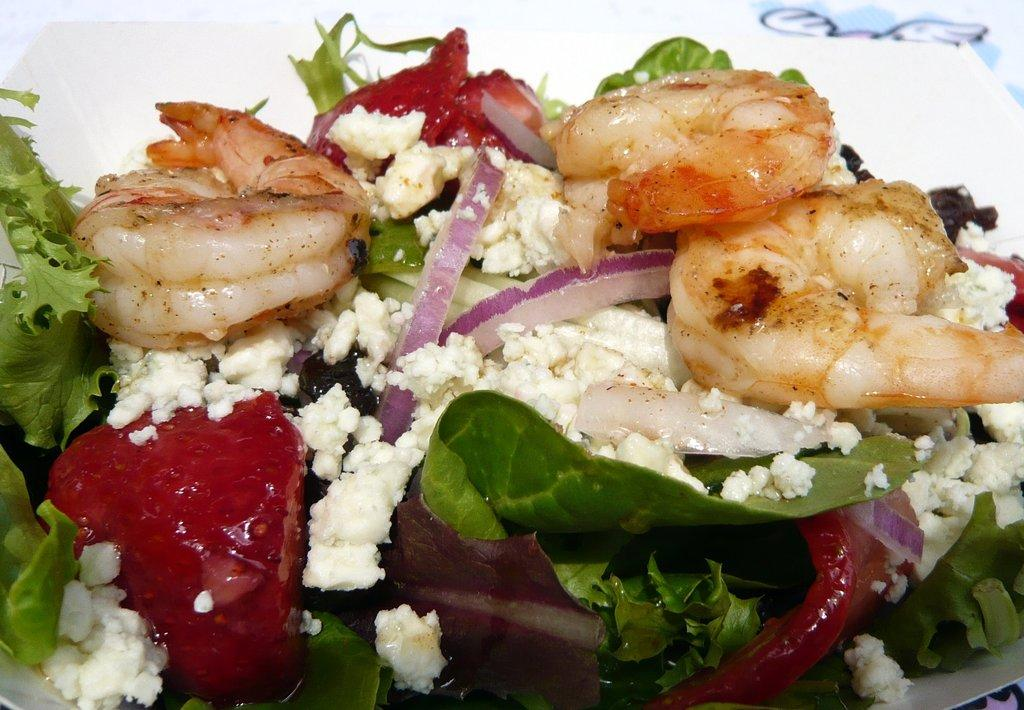What is on the plate that is visible in the image? There are prawns on the plate in the image. Are there any other food items on the plate besides the prawns? Yes, there are other food items on the plate in the image. How many stars can be seen on the plate in the image? There are no stars visible on the plate in the image. Is there a slave depicted on the plate in the image? There is no depiction of a slave or any human figure on the plate in the image. 